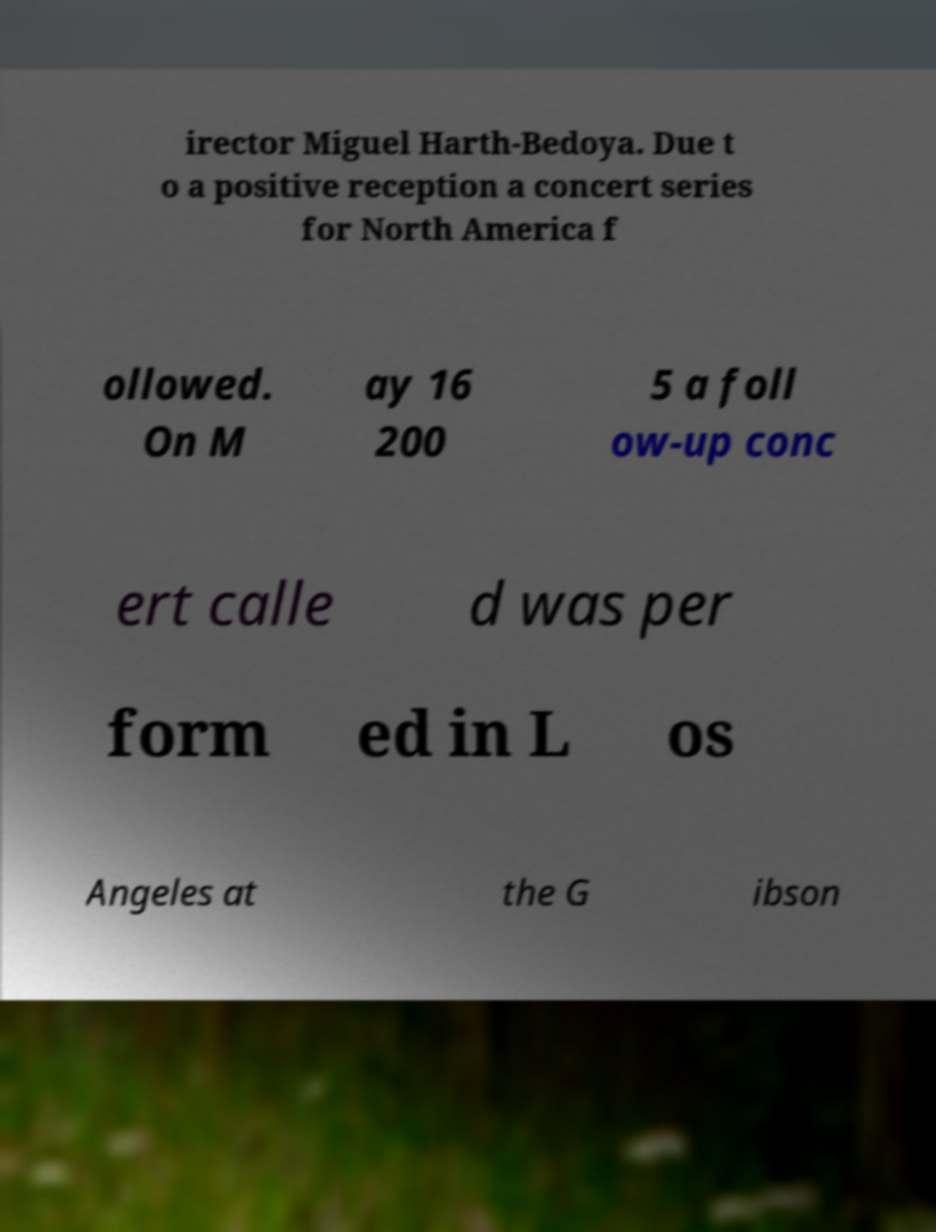Please identify and transcribe the text found in this image. irector Miguel Harth-Bedoya. Due t o a positive reception a concert series for North America f ollowed. On M ay 16 200 5 a foll ow-up conc ert calle d was per form ed in L os Angeles at the G ibson 